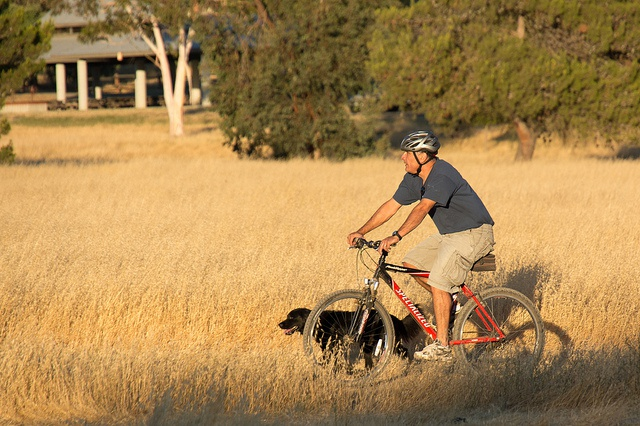Describe the objects in this image and their specific colors. I can see bicycle in olive, gray, tan, and black tones, people in olive, gray, and tan tones, and dog in olive, black, tan, and maroon tones in this image. 